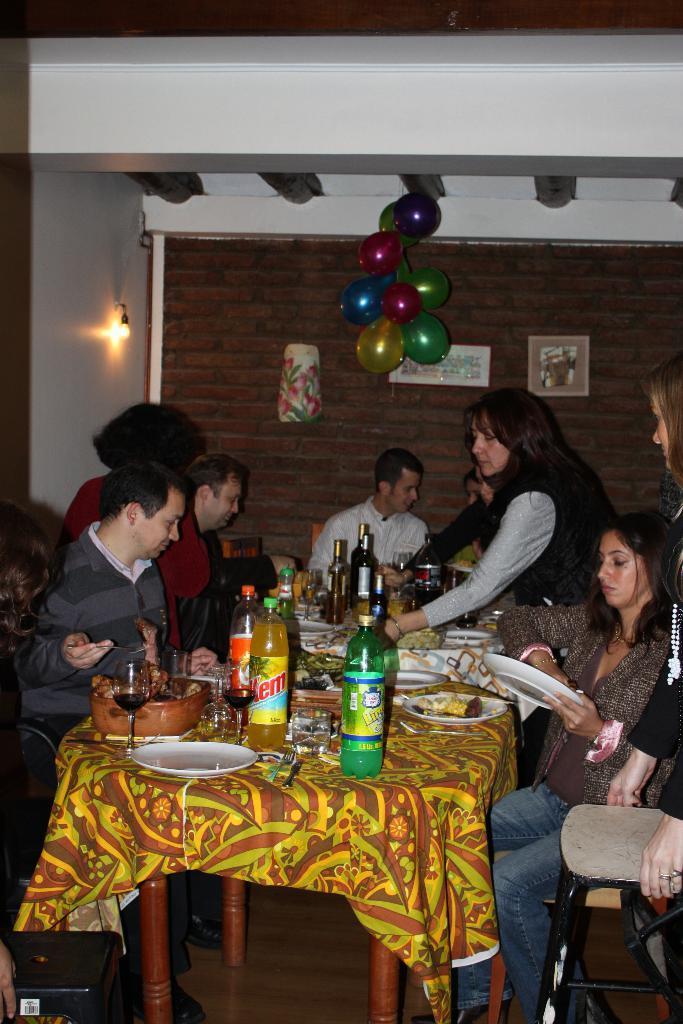How would you summarize this image in a sentence or two? In this image there are group of people sitting on a dining table and some of them are standing having food the woman at the right side is sitting on a chair and is holding a plate and cleaning it, the woman at the right side is serving the food. The man in the center is smiling. The persons at the left side is looking at the food which is on the table. The table is covered with a yellow colour cloth and it is filled with plates with a food on it and the bottles and glass with a drink in it. In the background there is a ball balloons hanged to the roof roof and frames attached to the walls and light is on. 